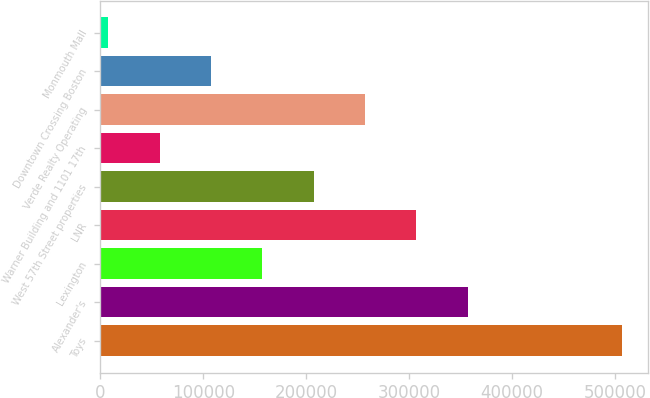<chart> <loc_0><loc_0><loc_500><loc_500><bar_chart><fcel>Toys<fcel>Alexander's<fcel>Lexington<fcel>LNR<fcel>West 57th Street properties<fcel>Warner Building and 1101 17th<fcel>Verde Realty Operating<fcel>Downtown Crossing Boston<fcel>Monmouth Mall<nl><fcel>506809<fcel>357027<fcel>157318<fcel>307100<fcel>207245<fcel>57463.3<fcel>257172<fcel>107391<fcel>7536<nl></chart> 